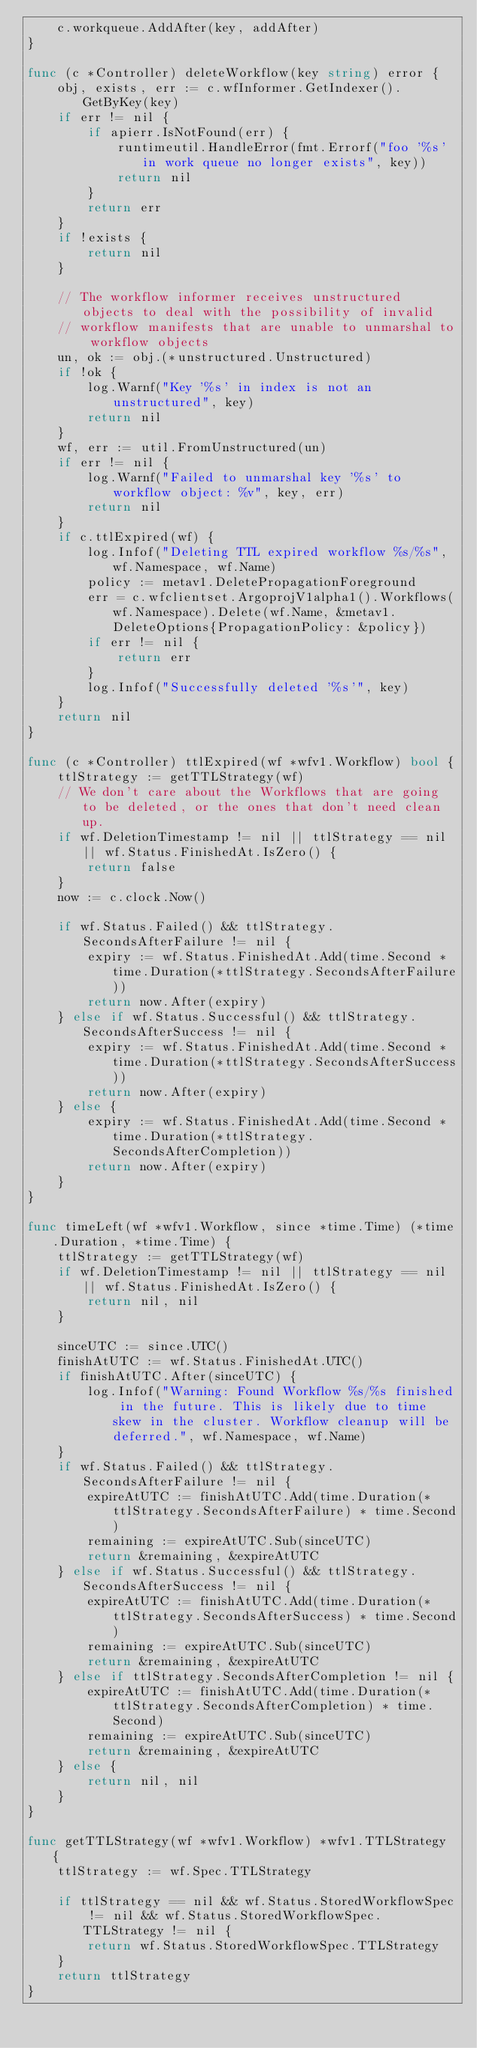Convert code to text. <code><loc_0><loc_0><loc_500><loc_500><_Go_>	c.workqueue.AddAfter(key, addAfter)
}

func (c *Controller) deleteWorkflow(key string) error {
	obj, exists, err := c.wfInformer.GetIndexer().GetByKey(key)
	if err != nil {
		if apierr.IsNotFound(err) {
			runtimeutil.HandleError(fmt.Errorf("foo '%s' in work queue no longer exists", key))
			return nil
		}
		return err
	}
	if !exists {
		return nil
	}

	// The workflow informer receives unstructured objects to deal with the possibility of invalid
	// workflow manifests that are unable to unmarshal to workflow objects
	un, ok := obj.(*unstructured.Unstructured)
	if !ok {
		log.Warnf("Key '%s' in index is not an unstructured", key)
		return nil
	}
	wf, err := util.FromUnstructured(un)
	if err != nil {
		log.Warnf("Failed to unmarshal key '%s' to workflow object: %v", key, err)
		return nil
	}
	if c.ttlExpired(wf) {
		log.Infof("Deleting TTL expired workflow %s/%s", wf.Namespace, wf.Name)
		policy := metav1.DeletePropagationForeground
		err = c.wfclientset.ArgoprojV1alpha1().Workflows(wf.Namespace).Delete(wf.Name, &metav1.DeleteOptions{PropagationPolicy: &policy})
		if err != nil {
			return err
		}
		log.Infof("Successfully deleted '%s'", key)
	}
	return nil
}

func (c *Controller) ttlExpired(wf *wfv1.Workflow) bool {
	ttlStrategy := getTTLStrategy(wf)
	// We don't care about the Workflows that are going to be deleted, or the ones that don't need clean up.
	if wf.DeletionTimestamp != nil || ttlStrategy == nil || wf.Status.FinishedAt.IsZero() {
		return false
	}
	now := c.clock.Now()

	if wf.Status.Failed() && ttlStrategy.SecondsAfterFailure != nil {
		expiry := wf.Status.FinishedAt.Add(time.Second * time.Duration(*ttlStrategy.SecondsAfterFailure))
		return now.After(expiry)
	} else if wf.Status.Successful() && ttlStrategy.SecondsAfterSuccess != nil {
		expiry := wf.Status.FinishedAt.Add(time.Second * time.Duration(*ttlStrategy.SecondsAfterSuccess))
		return now.After(expiry)
	} else {
		expiry := wf.Status.FinishedAt.Add(time.Second * time.Duration(*ttlStrategy.SecondsAfterCompletion))
		return now.After(expiry)
	}
}

func timeLeft(wf *wfv1.Workflow, since *time.Time) (*time.Duration, *time.Time) {
	ttlStrategy := getTTLStrategy(wf)
	if wf.DeletionTimestamp != nil || ttlStrategy == nil || wf.Status.FinishedAt.IsZero() {
		return nil, nil
	}

	sinceUTC := since.UTC()
	finishAtUTC := wf.Status.FinishedAt.UTC()
	if finishAtUTC.After(sinceUTC) {
		log.Infof("Warning: Found Workflow %s/%s finished in the future. This is likely due to time skew in the cluster. Workflow cleanup will be deferred.", wf.Namespace, wf.Name)
	}
	if wf.Status.Failed() && ttlStrategy.SecondsAfterFailure != nil {
		expireAtUTC := finishAtUTC.Add(time.Duration(*ttlStrategy.SecondsAfterFailure) * time.Second)
		remaining := expireAtUTC.Sub(sinceUTC)
		return &remaining, &expireAtUTC
	} else if wf.Status.Successful() && ttlStrategy.SecondsAfterSuccess != nil {
		expireAtUTC := finishAtUTC.Add(time.Duration(*ttlStrategy.SecondsAfterSuccess) * time.Second)
		remaining := expireAtUTC.Sub(sinceUTC)
		return &remaining, &expireAtUTC
	} else if ttlStrategy.SecondsAfterCompletion != nil {
		expireAtUTC := finishAtUTC.Add(time.Duration(*ttlStrategy.SecondsAfterCompletion) * time.Second)
		remaining := expireAtUTC.Sub(sinceUTC)
		return &remaining, &expireAtUTC
	} else {
		return nil, nil
	}
}

func getTTLStrategy(wf *wfv1.Workflow) *wfv1.TTLStrategy {
	ttlStrategy := wf.Spec.TTLStrategy

	if ttlStrategy == nil && wf.Status.StoredWorkflowSpec != nil && wf.Status.StoredWorkflowSpec.TTLStrategy != nil {
		return wf.Status.StoredWorkflowSpec.TTLStrategy
	}
	return ttlStrategy
}
</code> 